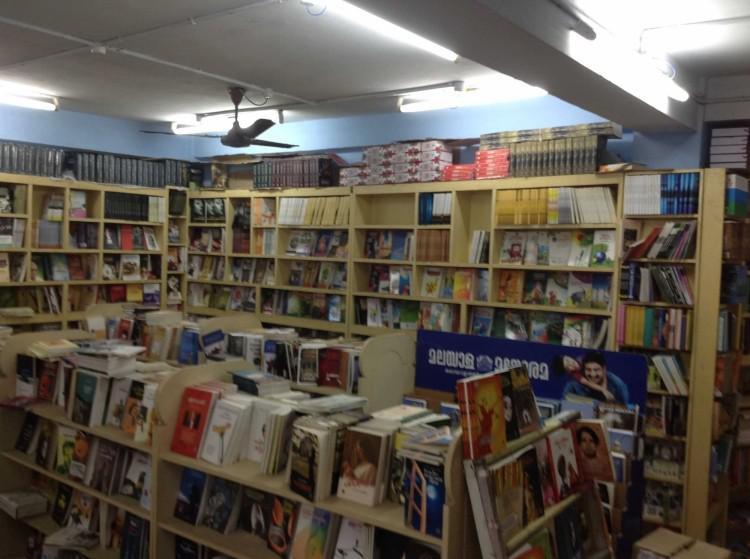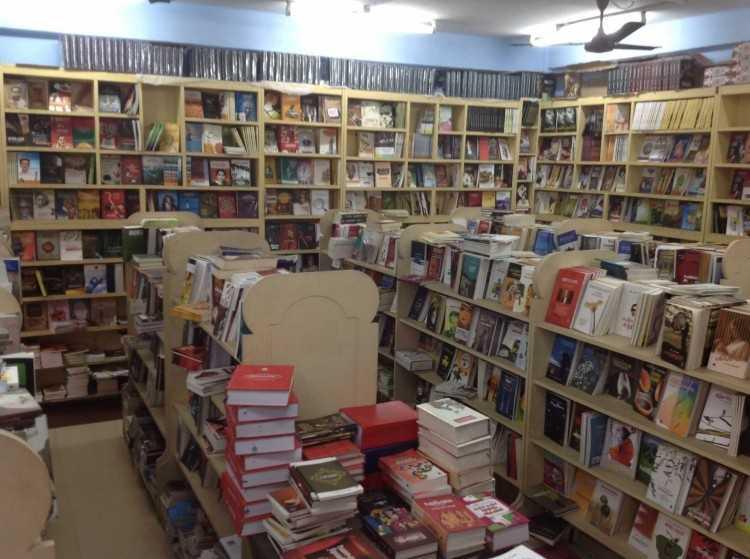The first image is the image on the left, the second image is the image on the right. For the images displayed, is the sentence "Shelves line the wall in the bookstore." factually correct? Answer yes or no. Yes. The first image is the image on the left, the second image is the image on the right. Evaluate the accuracy of this statement regarding the images: "All images contain books stored on book shelves.". Is it true? Answer yes or no. Yes. 